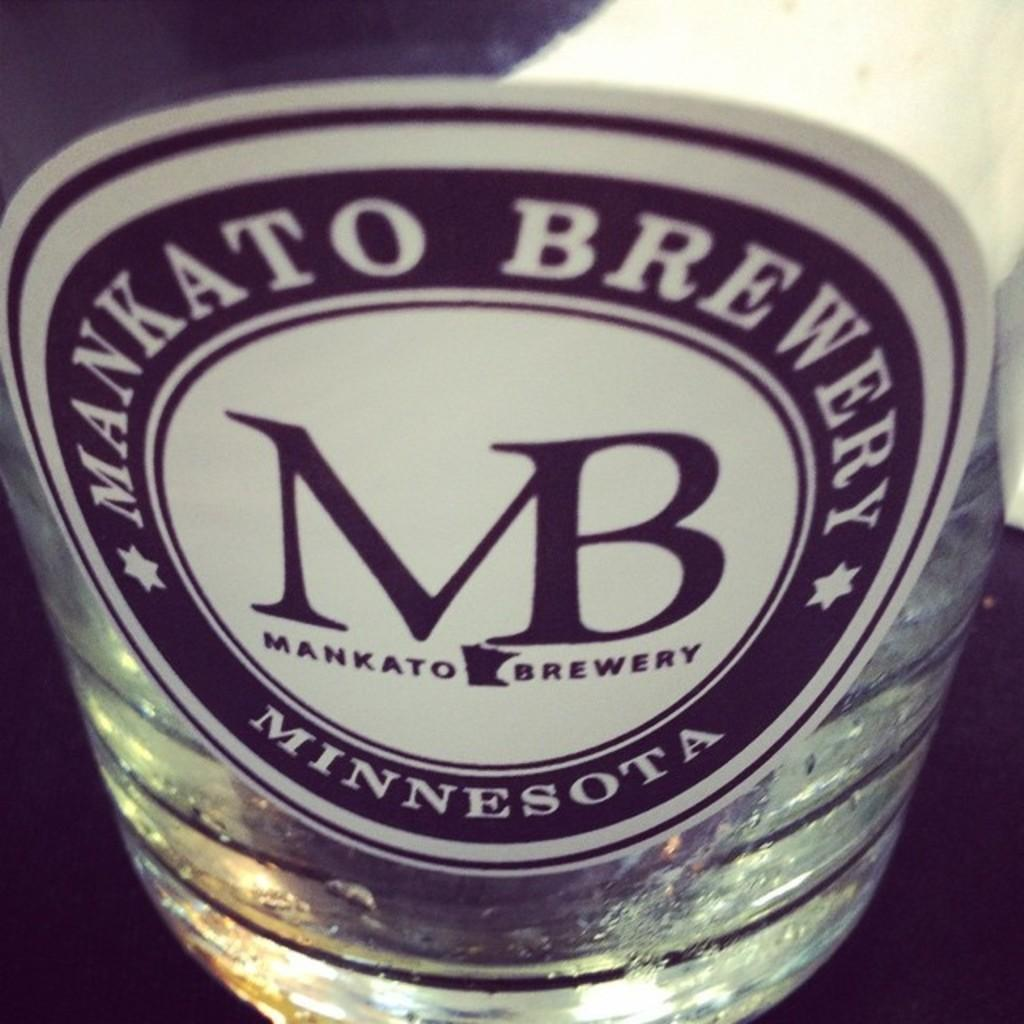What object can be seen in the image? There is a bottle in the image. Is there anything on the bottle? Yes, there is a sticker attached to the bottle. What type of toys can be seen in the image? There are no toys present in the image; it only features a bottle with a sticker. 